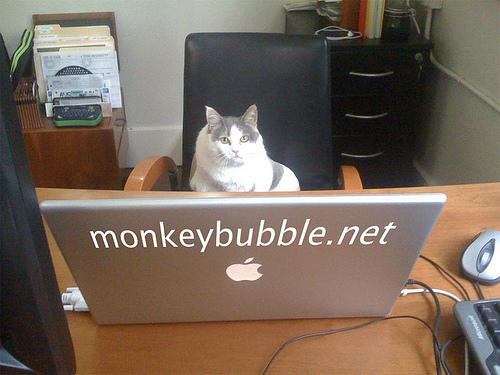Evaluate the scene and suggest the possible sentiment linked to the image. The image has a lighthearted and humorous sentiment, with the cat seemingly using the computer. Can you identify the type of office supplies shown in the image and explain where they are located? There is a stack of manila folders on the left and a black filing cabinet at the back of the image. How many objects are there on the desk that are used to control a computer? There are two objects, a black and gray wired computer mouse and a black and gray keyboard. What type of electronic device is the primary focus of the image? The silver Apple laptop with an open lid and lit up logo is the primary focus of the image. Please describe the items related to the technology present in the image. The image includes an open silver Apple laptop with lit up logo, a black and gray wired computer mouse, and a black and gray keyboard. What kind of office furniture can be seen in the image apart from the chair? A black filing cabinet and a wooden file cabinet are visible in the image. What type of animal is prominently visible in the image and mention its color? A gray and white cat is prominently visible in the image. Determine the number of cats in the image and where they are positioned. There is one cat in the image, sitting on a chair in front of a laptop. Describe the chair visible in the image, including its color and additional features. The chair is black with wood handles, and it has armrests. Explain the position and action of the cat in relation to the laptop. The cat is sitting in front of the laptop, facing it, as if it's looking at the screen or interacting with the laptop. 